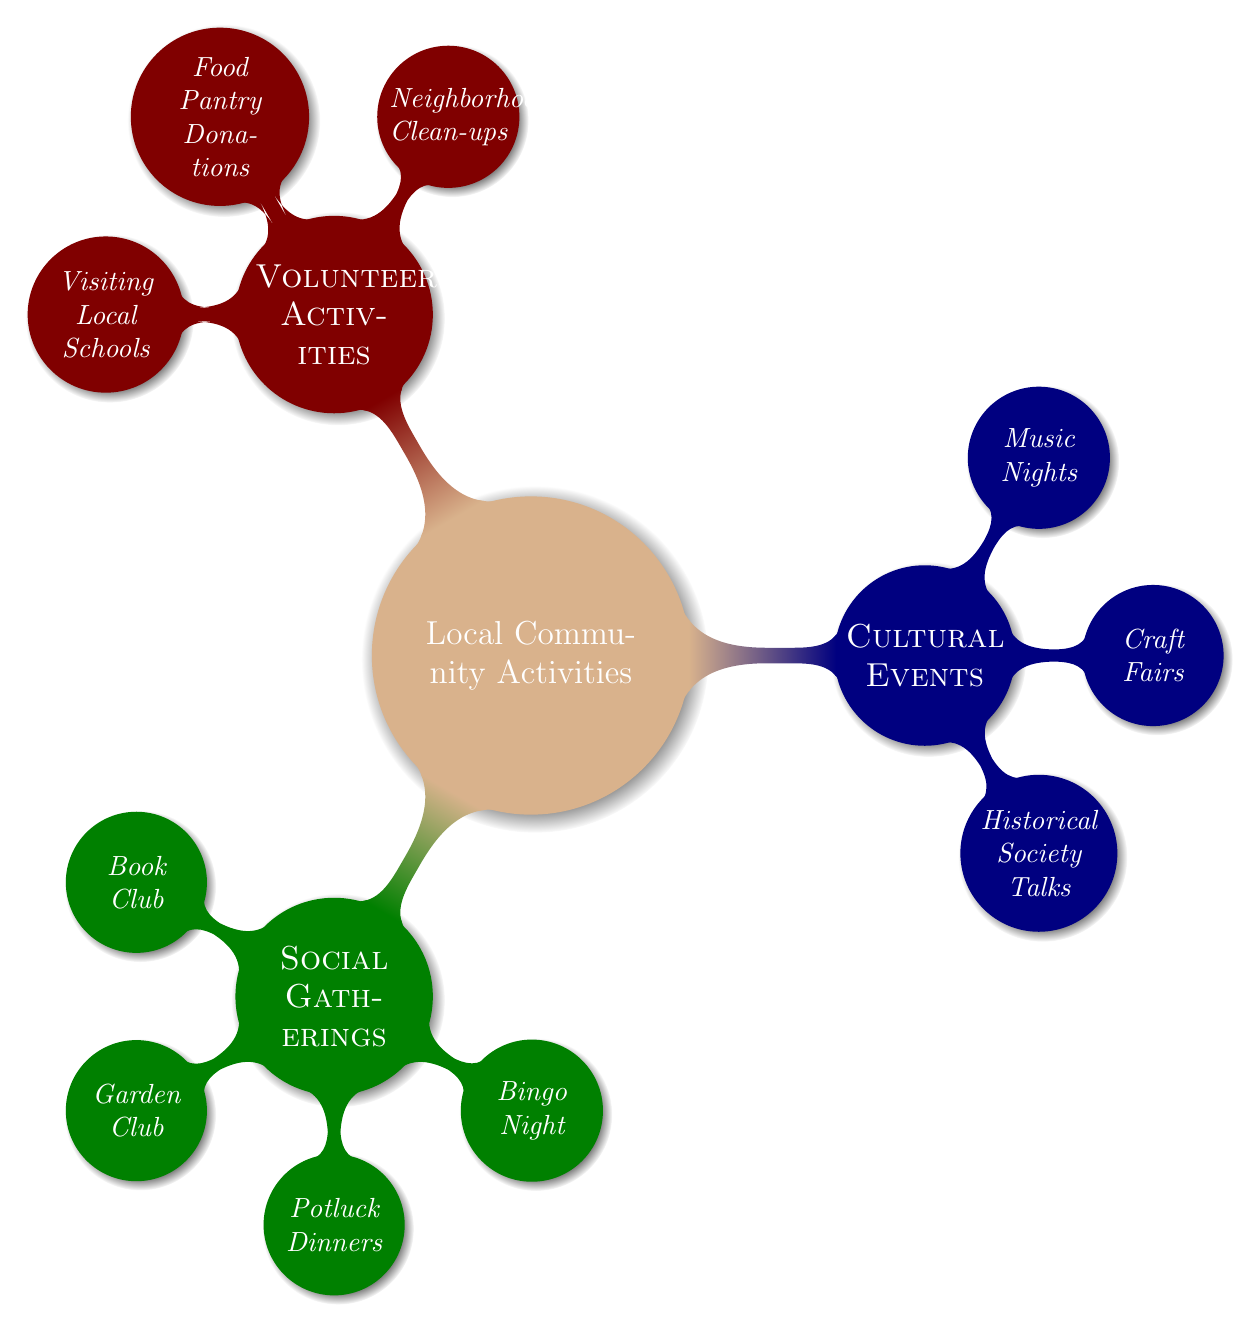What are the three main categories of local community activities? The main nodes in the mind map represent the three categories: Social Gatherings, Cultural Events, and Volunteer Activities. These serve as the primary categories under "Local Community Activities."
Answer: Social Gatherings, Cultural Events, Volunteer Activities How many events are listed under Social Gatherings? By examining the "Social Gatherings" node, we can count the events listed: Book Club, Garden Club, Potluck Dinners, and Bingo Night, which totals four events.
Answer: 4 Which event takes place on the first Friday of the month? Within the "Social Gatherings" category, the node "Bingo Night" explicitly states it occurs on the first Friday of the month, making it the correct answer.
Answer: Bingo Night What is the last event scheduled for the month in Cultural Events? By looking at the "Cultural Events" node, we identify "Historical Society Talks" as the last event which occurs on the last Sunday of the month.
Answer: Historical Society Talks What volunteer activity occurs on the first Saturday of the month? The node "Neighborhood Clean-ups" under "Volunteer Activities" specifies that this event occurs on the first Saturday of the month, thus answering the question.
Answer: Neighborhood Clean-ups Which event is held every third Thursday at the Community Center? Checking the "Food Pantry Donations" node in "Volunteer Activities" reveals that this event occurs every third Thursday at the Community Center, providing the needed answer.
Answer: Food Pantry Donations How many different social gatherings are listed? By referencing the "Social Gatherings" section, we see there are four different events, which leads us to the total count when asked.
Answer: 4 Which activity connects to sharing stories with local schools? When looking under "Volunteer Activities," the node indicates "Visiting Local Schools" is the activity aimed at sharing stories and history, thus providing the direct connection.
Answer: Visiting Local Schools 